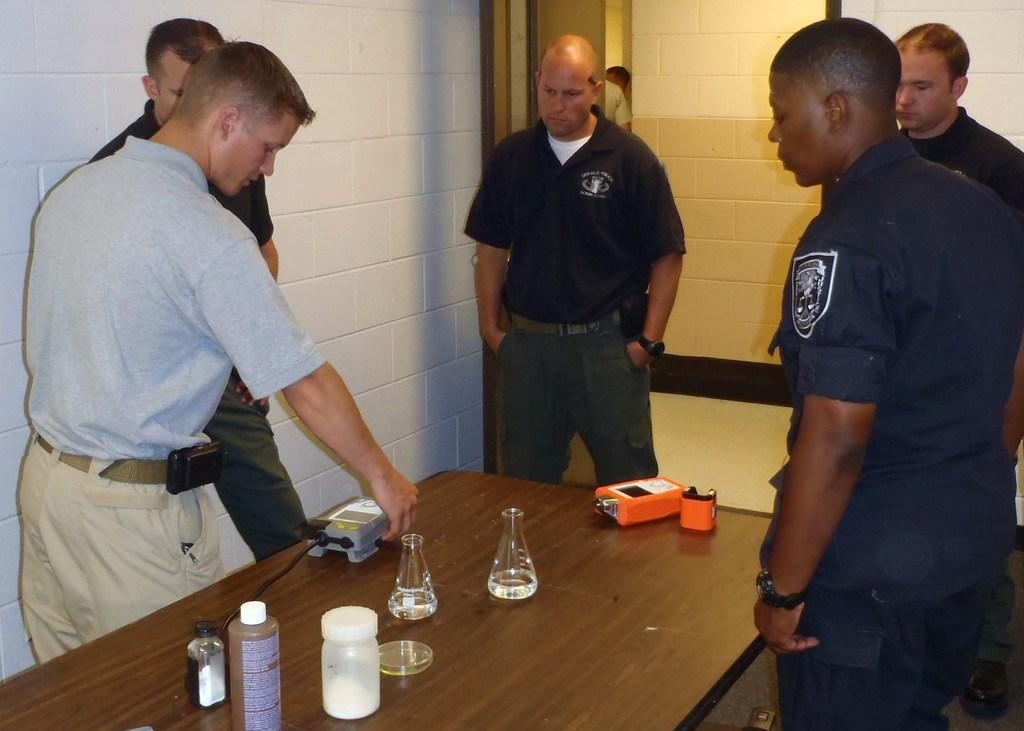How many people are in the image? There is a group of people in the image, but the exact number is not specified. What are the people in the image doing? The people are standing in the image. What is on the table in the image? There is a glass, a bottle, and a currency counting machine on the table in the image. What can be seen in the background of the image? There is a wall visible in the background of the image. What type of cow can be seen grazing near the people in the image? There is no cow present in the image; it features a group of people standing near a table with various objects. What type of skin is visible on the people in the image? The image does not show the skin of the people; it only shows their standing posture. 